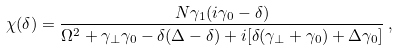<formula> <loc_0><loc_0><loc_500><loc_500>\chi ( \delta ) = \frac { N \gamma _ { 1 } ( i \gamma _ { 0 } - \delta ) } { \Omega ^ { 2 } + \gamma _ { \perp } \gamma _ { 0 } - \delta ( \Delta - \delta ) + i [ \delta ( \gamma _ { \perp } + \gamma _ { 0 } ) + \Delta \gamma _ { 0 } ] } \, ,</formula> 